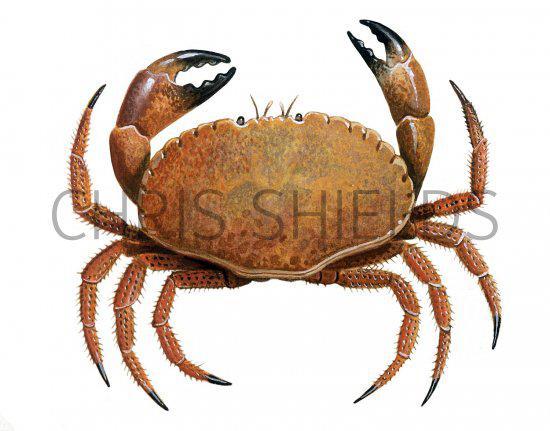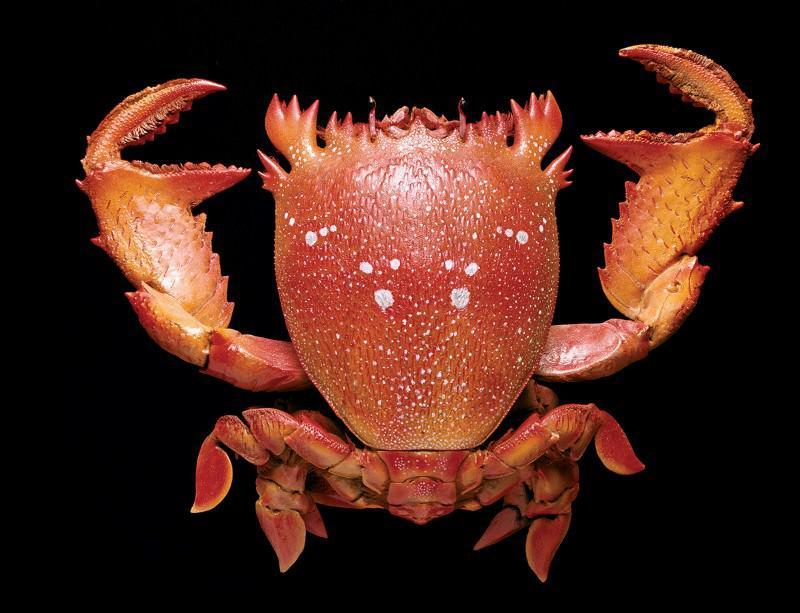The first image is the image on the left, the second image is the image on the right. For the images displayed, is the sentence "Each image shows a top-view of a crab with its face and its larger front claws at the top, and its shell facing forward." factually correct? Answer yes or no. Yes. The first image is the image on the left, the second image is the image on the right. Considering the images on both sides, is "The crabs have the same orientation." valid? Answer yes or no. Yes. 